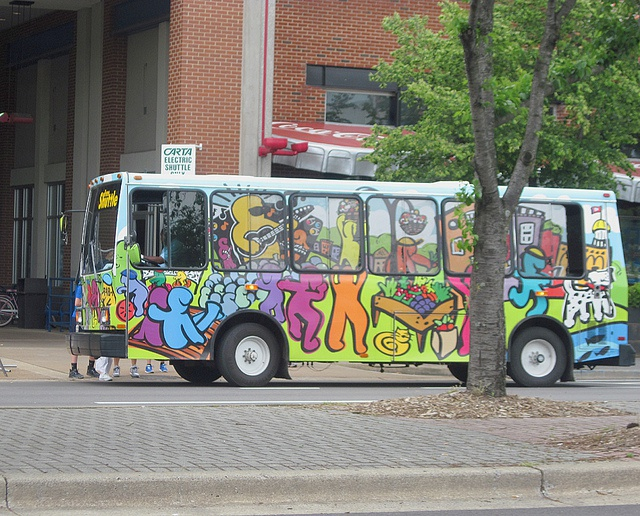Describe the objects in this image and their specific colors. I can see bus in black, gray, lightgray, and darkgray tones, people in black, lightblue, and navy tones, people in black, gray, purple, and darkblue tones, bicycle in black, gray, and navy tones, and people in black, lavender, gray, darkgray, and lightblue tones in this image. 